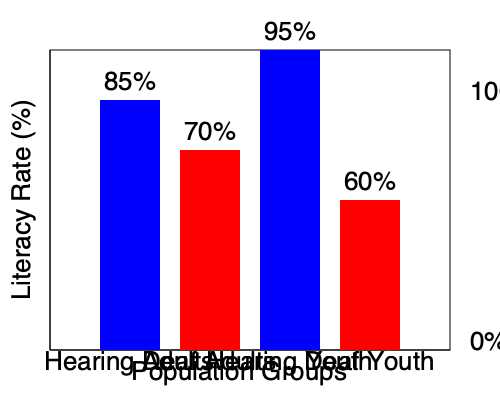Based on the bar graph comparing literacy rates among deaf and hearing populations, what is the difference in literacy rates between hearing and deaf youth? To find the difference in literacy rates between hearing and deaf youth, we need to:

1. Identify the literacy rate for hearing youth:
   The blue bar for "Hearing Youth" shows a literacy rate of 95%.

2. Identify the literacy rate for deaf youth:
   The red bar for "Deaf Youth" shows a literacy rate of 60%.

3. Calculate the difference:
   $95\% - 60\% = 35\%$

This calculation shows that there is a 35 percentage point difference in literacy rates between hearing and deaf youth, with hearing youth having a higher literacy rate.
Answer: 35 percentage points 